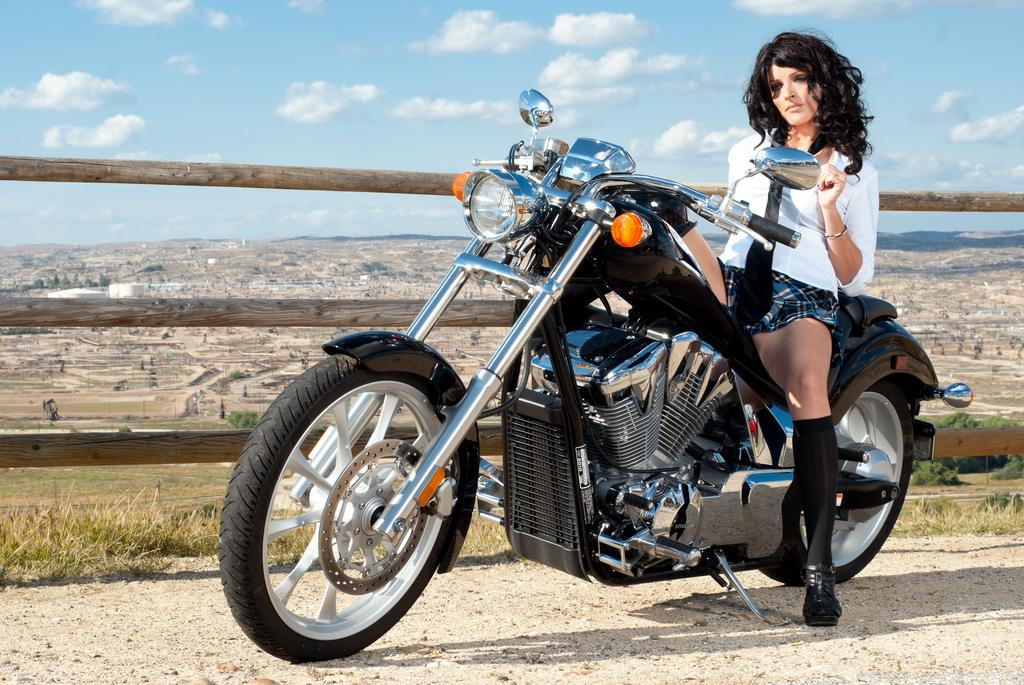Who is the main subject in the image? There is a woman in the image. What is the woman doing in the image? The woman is sitting on a bike. What is the woman wearing in the image? The woman is wearing a white shirt and a skirt. What can be seen in the image besides the woman and her bike? There are wheels, grass, the sky, and wooden fencing visible in the image. Is the woman sinking in quicksand in the image? No, there is no quicksand present in the image. The woman is sitting on a bike on grass, and there is no indication of quicksand. 